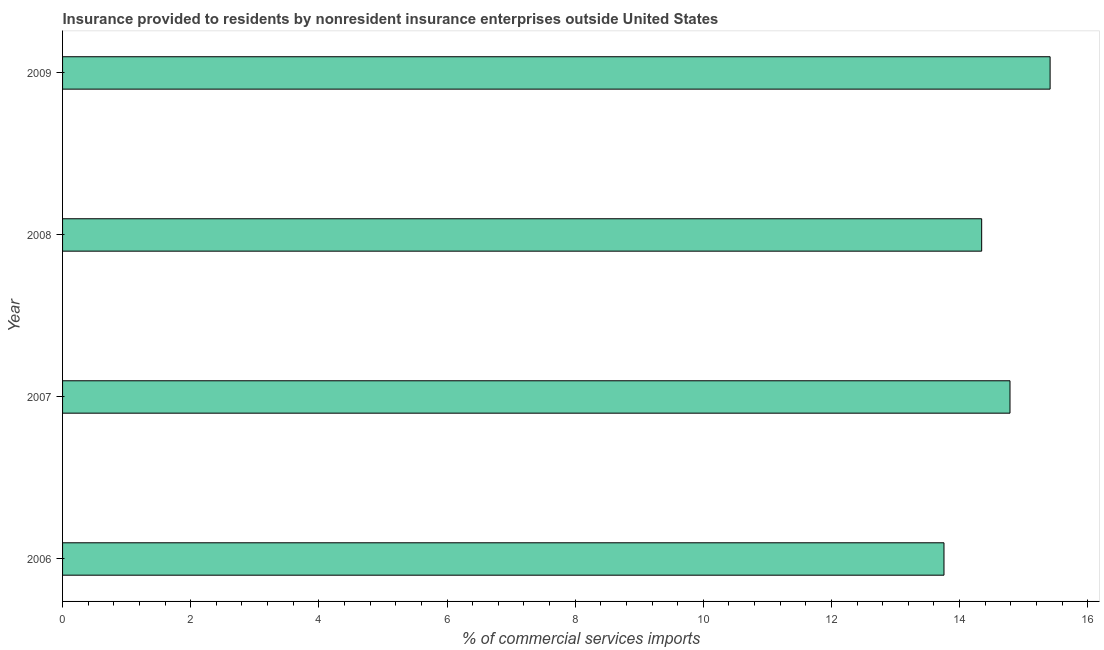Does the graph contain any zero values?
Provide a succinct answer. No. Does the graph contain grids?
Provide a succinct answer. No. What is the title of the graph?
Your answer should be compact. Insurance provided to residents by nonresident insurance enterprises outside United States. What is the label or title of the X-axis?
Your answer should be compact. % of commercial services imports. What is the label or title of the Y-axis?
Your answer should be very brief. Year. What is the insurance provided by non-residents in 2007?
Your answer should be very brief. 14.79. Across all years, what is the maximum insurance provided by non-residents?
Provide a succinct answer. 15.41. Across all years, what is the minimum insurance provided by non-residents?
Give a very brief answer. 13.76. In which year was the insurance provided by non-residents maximum?
Your response must be concise. 2009. In which year was the insurance provided by non-residents minimum?
Make the answer very short. 2006. What is the sum of the insurance provided by non-residents?
Offer a very short reply. 58.3. What is the difference between the insurance provided by non-residents in 2007 and 2008?
Your response must be concise. 0.44. What is the average insurance provided by non-residents per year?
Keep it short and to the point. 14.57. What is the median insurance provided by non-residents?
Your answer should be very brief. 14.57. Do a majority of the years between 2009 and 2006 (inclusive) have insurance provided by non-residents greater than 12.8 %?
Your answer should be compact. Yes. What is the difference between the highest and the second highest insurance provided by non-residents?
Provide a short and direct response. 0.63. Is the sum of the insurance provided by non-residents in 2007 and 2009 greater than the maximum insurance provided by non-residents across all years?
Offer a terse response. Yes. What is the difference between the highest and the lowest insurance provided by non-residents?
Provide a succinct answer. 1.66. In how many years, is the insurance provided by non-residents greater than the average insurance provided by non-residents taken over all years?
Your answer should be very brief. 2. Are all the bars in the graph horizontal?
Offer a very short reply. Yes. What is the difference between two consecutive major ticks on the X-axis?
Your answer should be compact. 2. Are the values on the major ticks of X-axis written in scientific E-notation?
Provide a succinct answer. No. What is the % of commercial services imports in 2006?
Give a very brief answer. 13.76. What is the % of commercial services imports in 2007?
Provide a short and direct response. 14.79. What is the % of commercial services imports in 2008?
Give a very brief answer. 14.34. What is the % of commercial services imports of 2009?
Make the answer very short. 15.41. What is the difference between the % of commercial services imports in 2006 and 2007?
Your answer should be very brief. -1.03. What is the difference between the % of commercial services imports in 2006 and 2008?
Your answer should be very brief. -0.59. What is the difference between the % of commercial services imports in 2006 and 2009?
Keep it short and to the point. -1.66. What is the difference between the % of commercial services imports in 2007 and 2008?
Provide a succinct answer. 0.44. What is the difference between the % of commercial services imports in 2007 and 2009?
Provide a short and direct response. -0.63. What is the difference between the % of commercial services imports in 2008 and 2009?
Offer a terse response. -1.07. What is the ratio of the % of commercial services imports in 2006 to that in 2007?
Offer a terse response. 0.93. What is the ratio of the % of commercial services imports in 2006 to that in 2008?
Your answer should be compact. 0.96. What is the ratio of the % of commercial services imports in 2006 to that in 2009?
Provide a short and direct response. 0.89. What is the ratio of the % of commercial services imports in 2007 to that in 2008?
Ensure brevity in your answer.  1.03. What is the ratio of the % of commercial services imports in 2007 to that in 2009?
Your answer should be compact. 0.96. 